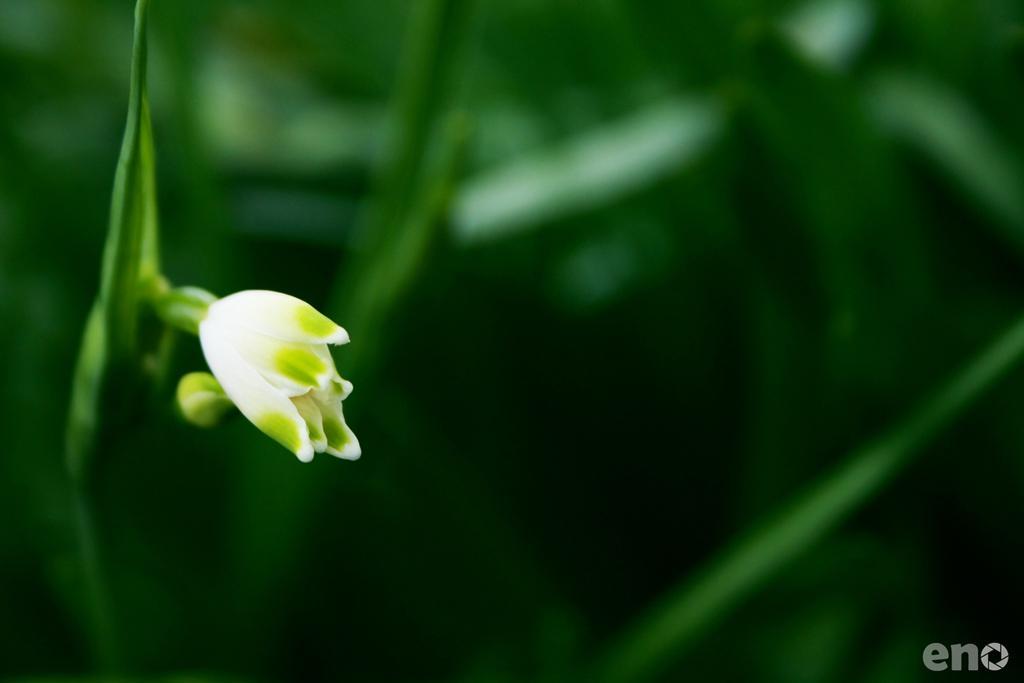Can you describe this image briefly? To the left side of the image there is a white flower with green leaves. In the background there is a green color. And to the right bottom corner of the image there is an eno name on it. 